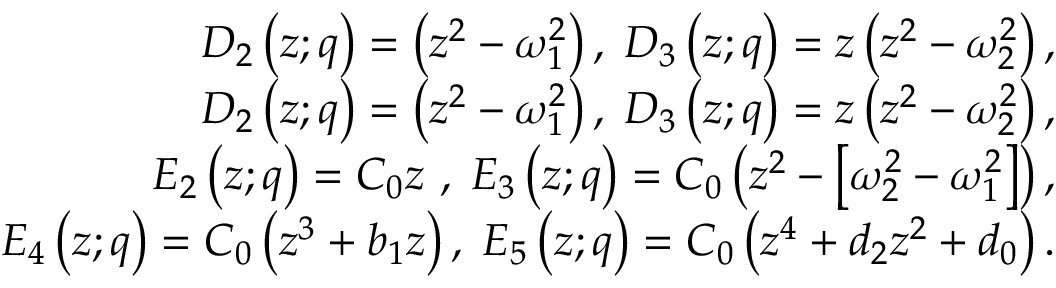Convert formula to latex. <formula><loc_0><loc_0><loc_500><loc_500>\begin{array} { r l r } & { D _ { 2 } \left ( z ; q \right ) = \left ( z ^ { 2 } - \omega _ { 1 } ^ { 2 } \right ) , \, D _ { 3 } \left ( z ; q \right ) = z \left ( z ^ { 2 } - \omega _ { 2 } ^ { 2 } \right ) , } \\ & { D _ { 2 } \left ( z ; q \right ) = \left ( z ^ { 2 } - \omega _ { 1 } ^ { 2 } \right ) , \, D _ { 3 } \left ( z ; q \right ) = z \left ( z ^ { 2 } - \omega _ { 2 } ^ { 2 } \right ) , } \\ & { E _ { 2 } \left ( z ; q \right ) = C _ { 0 } z \ , \, E _ { 3 } \left ( z ; q \right ) = C _ { 0 } \left ( z ^ { 2 } - \left [ \omega _ { 2 } ^ { 2 } - \omega _ { 1 } ^ { 2 } \right ] \right ) , } \\ & { E _ { 4 } \left ( z ; q \right ) = C _ { 0 } \left ( z ^ { 3 } + b _ { 1 } z \right ) , \, E _ { 5 } \left ( z ; q \right ) = C _ { 0 } \left ( z ^ { 4 } + d _ { 2 } z ^ { 2 } + d _ { 0 } \right ) . } \end{array}</formula> 